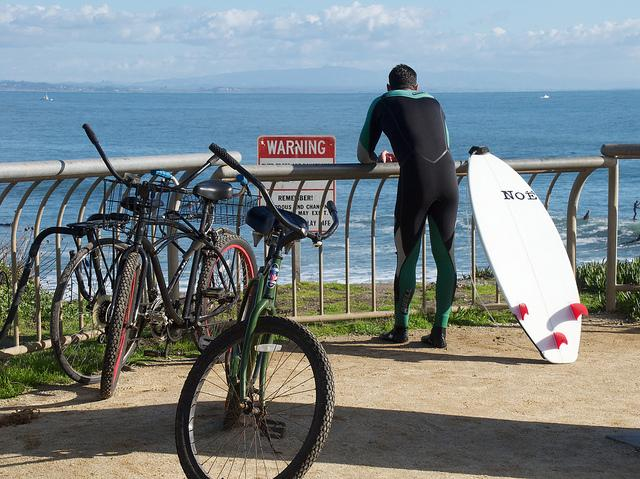What kind of surfboard it is? noe 